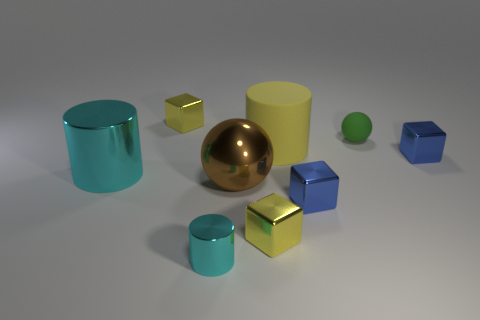Subtract all yellow cylinders. How many cylinders are left? 2 Subtract all spheres. How many objects are left? 7 Subtract all red balls. How many red cylinders are left? 0 Subtract all small cyan metallic cylinders. Subtract all small metallic cylinders. How many objects are left? 7 Add 3 large cylinders. How many large cylinders are left? 5 Add 5 rubber balls. How many rubber balls exist? 6 Subtract all yellow cylinders. How many cylinders are left? 2 Subtract 1 blue cubes. How many objects are left? 8 Subtract 1 cylinders. How many cylinders are left? 2 Subtract all green spheres. Subtract all yellow cylinders. How many spheres are left? 1 